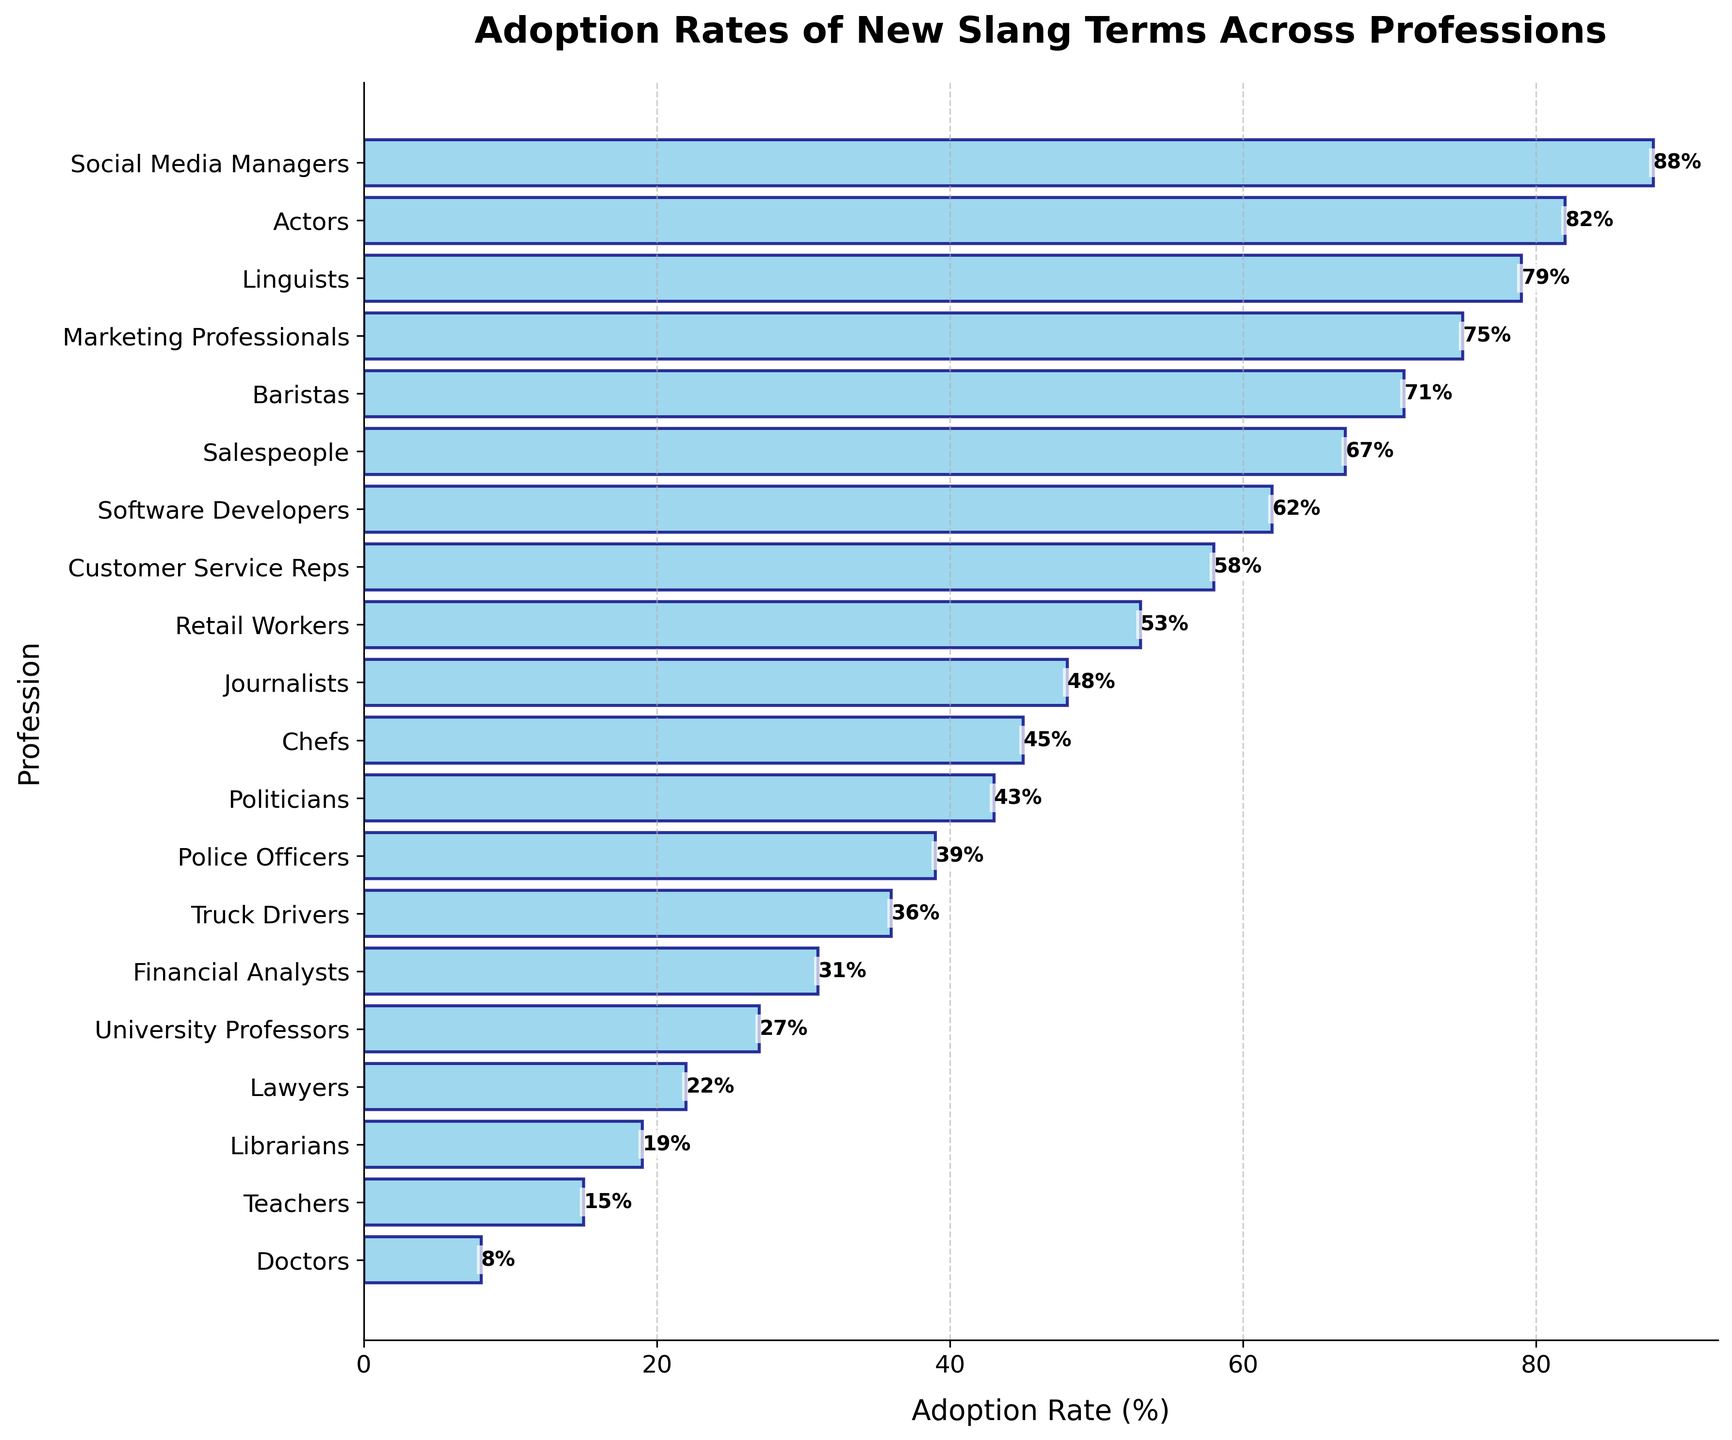Which profession has the highest adoption rate of new slang terms? Observe the bar chart and identify the profession with the longest bar. This profession will have the highest adoption rate.
Answer: Social Media Managers Which profession has the lowest adoption rate of new slang terms? Observe the bar chart and identify the profession with the shortest bar. This profession will have the lowest adoption rate.
Answer: Doctors What's the difference in adoption rates between Actors and Teachers? Find the adoption rates for Actors and Teachers, then subtract the rate of Teachers from the rate of Actors (82% - 15%).
Answer: 67% What's the average adoption rate across all the professions listed in the figure? To calculate the average, sum all the adoption rates and divide by the number of professions. Sum: 15 + 8 + 62 + 22 + 48 + 75 + 19 + 58 + 71 + 31 + 39 + 27 + 67 + 82 + 43 + 88 + 53 + 36 + 45 + 79 = 988. There are 20 professions, so the average is 988/20.
Answer: 49.4% Which profession has a higher adoption rate: Lawyers or Chefs? Compare the height of the bars for Lawyers and Chefs. Lawyers have an adoption rate of 22%, and Chefs have 45%.
Answer: Chefs How many professions have an adoption rate higher than 50%? Count the number of bars with lengths greater than 50%. These are Software Developers, Marketing Professionals, Baristas, Customer Service Reps, Salespeople, Actors, and Social Media Managers, Retail Workers, and Linguists.
Answer: 9 Which profession is exactly in the middle in terms of adoption rate? Arrange the adoption rates in ascending order, find the median value, and identify the corresponding profession. With 20 professions, the middle two values will be the 10th and 11th, which are 39% (Police Officers) and 43% (Politicians). The median value is the average of these two rates.
Answer: Politicians What’s the total adoption rate for Teachers, Librarians, and University Professors combined? Sum the adoption rates for Teachers (15%), Librarians (19%), and University Professors (27%). 15 + 19 + 27 = 61
Answer: 61% Which profession has an adoption rate closest to 50%? Look for the bar with a length nearest to 50% without exceeding it. Journalists have an adoption rate of 48%, the closest to 50%.
Answer: Journalists 